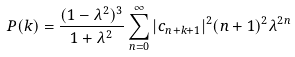Convert formula to latex. <formula><loc_0><loc_0><loc_500><loc_500>P ( k ) = \frac { ( 1 - \lambda ^ { 2 } ) ^ { 3 } } { 1 + \lambda ^ { 2 } } \sum _ { n = 0 } ^ { \infty } | c _ { n + k + 1 } | ^ { 2 } ( n + 1 ) ^ { 2 } \lambda ^ { 2 n }</formula> 